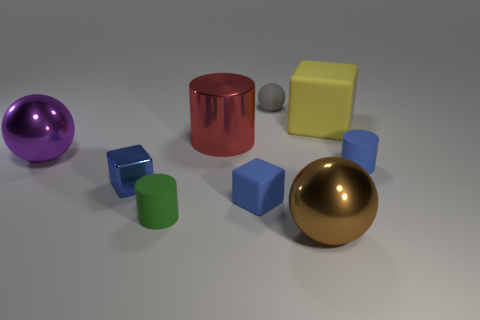Subtract all blue cylinders. How many blue cubes are left? 2 Subtract all blue metal blocks. How many blocks are left? 2 Subtract all blocks. How many objects are left? 6 Subtract 1 cylinders. How many cylinders are left? 2 Subtract all purple balls. Subtract all brown cubes. How many balls are left? 2 Subtract all tiny yellow metal spheres. Subtract all shiny objects. How many objects are left? 5 Add 2 large matte cubes. How many large matte cubes are left? 3 Add 9 purple spheres. How many purple spheres exist? 10 Subtract 1 brown balls. How many objects are left? 8 